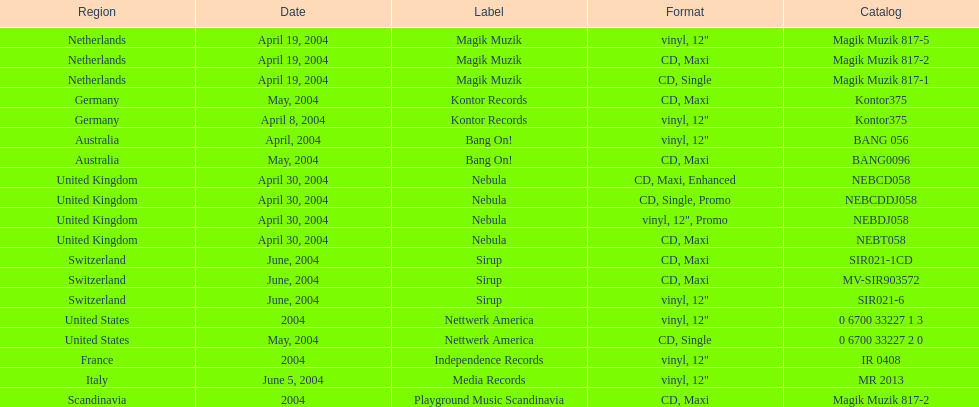What is the total number of catalogs published? 19. 